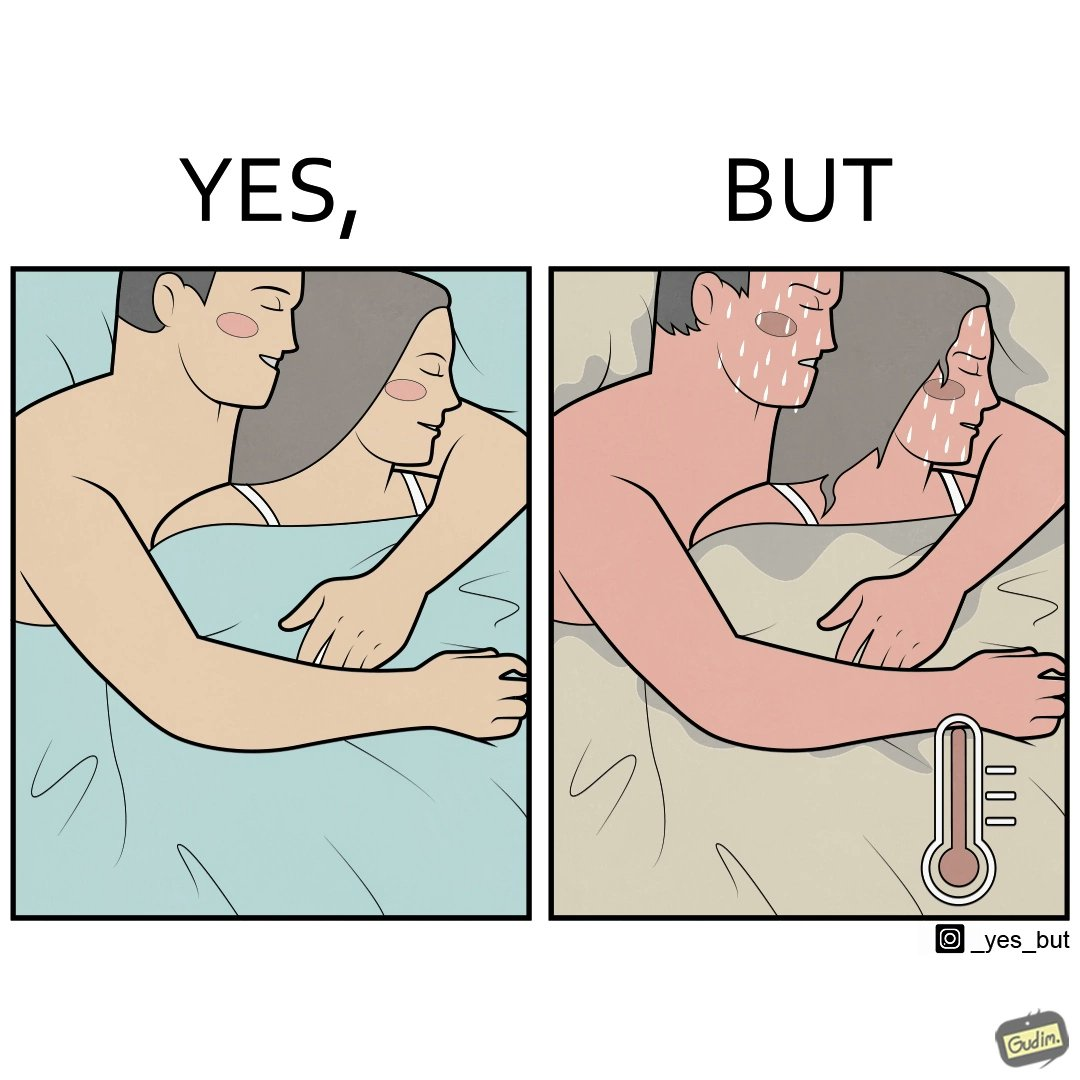Would you classify this image as satirical? Yes, this image is satirical. 